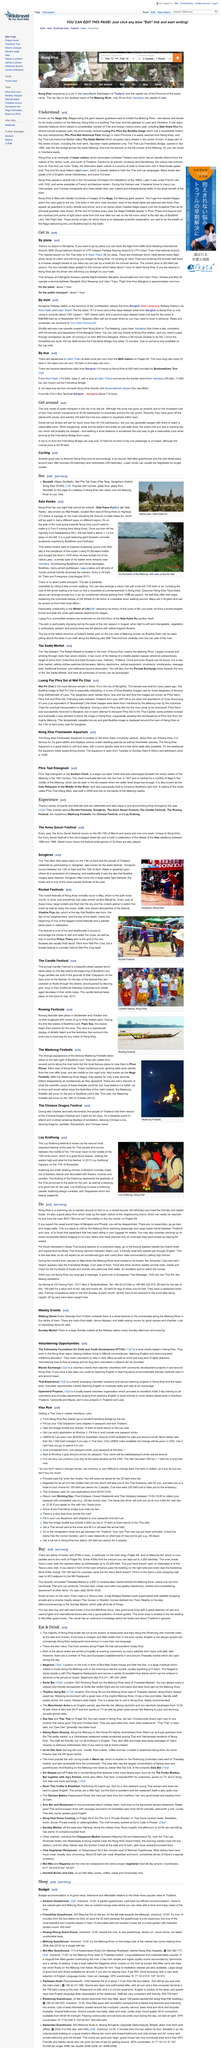Mention a couple of crucial points in this snapshot. The Thai-Lao Friendship Bridge was officially opened in April 1994, marking a significant milestone in cross-border infrastructure and economic development between Thailand and Laos. It is possible to travel by plane, and one can arrange for a flight by booking a flight from the airports in DMK, BKK, or UTP to the airport in UTH. Nagas are mythical giant serpent guardians believed to reside in the Mekong River. There is no airport in Nongkhai. Naga City is a place where pedestrians can travel around its center without the need for a vehicle, as a significant portion of the town, including the river bank, has been designated as a pedestrian-only zone. 